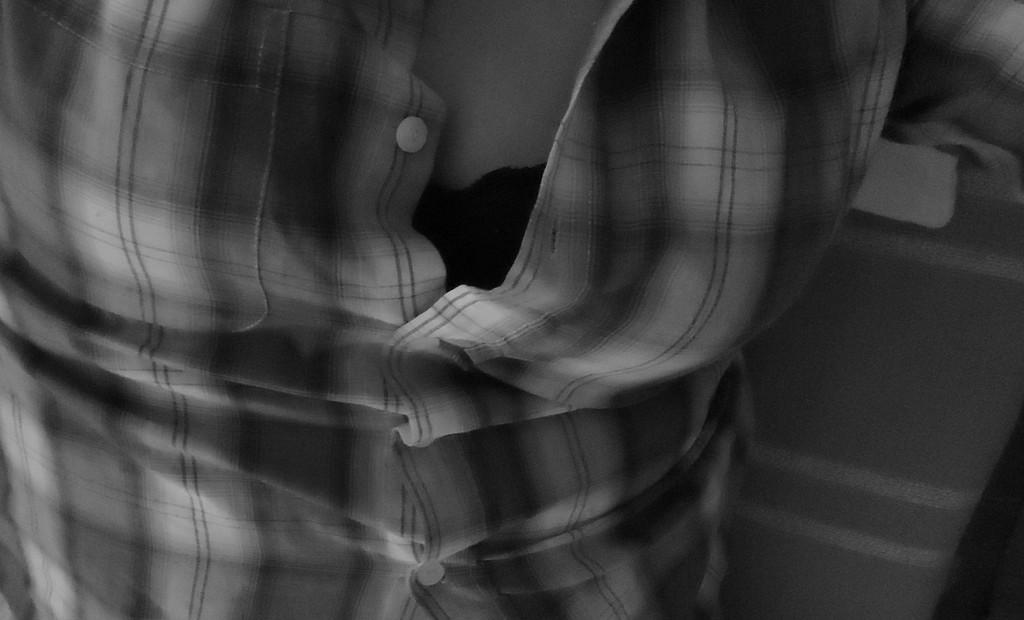What is the color scheme of the image? The image is black and white. Can you describe the main subject in the image? There is a person in the image. What is the person wearing in the image? The person is wearing a shirt. What type of coat is the person wearing in the image? There is no coat visible in the image, as the person is only wearing a shirt. What organization does the person represent in the image? The image does not provide any information about the person's affiliation or organization. 